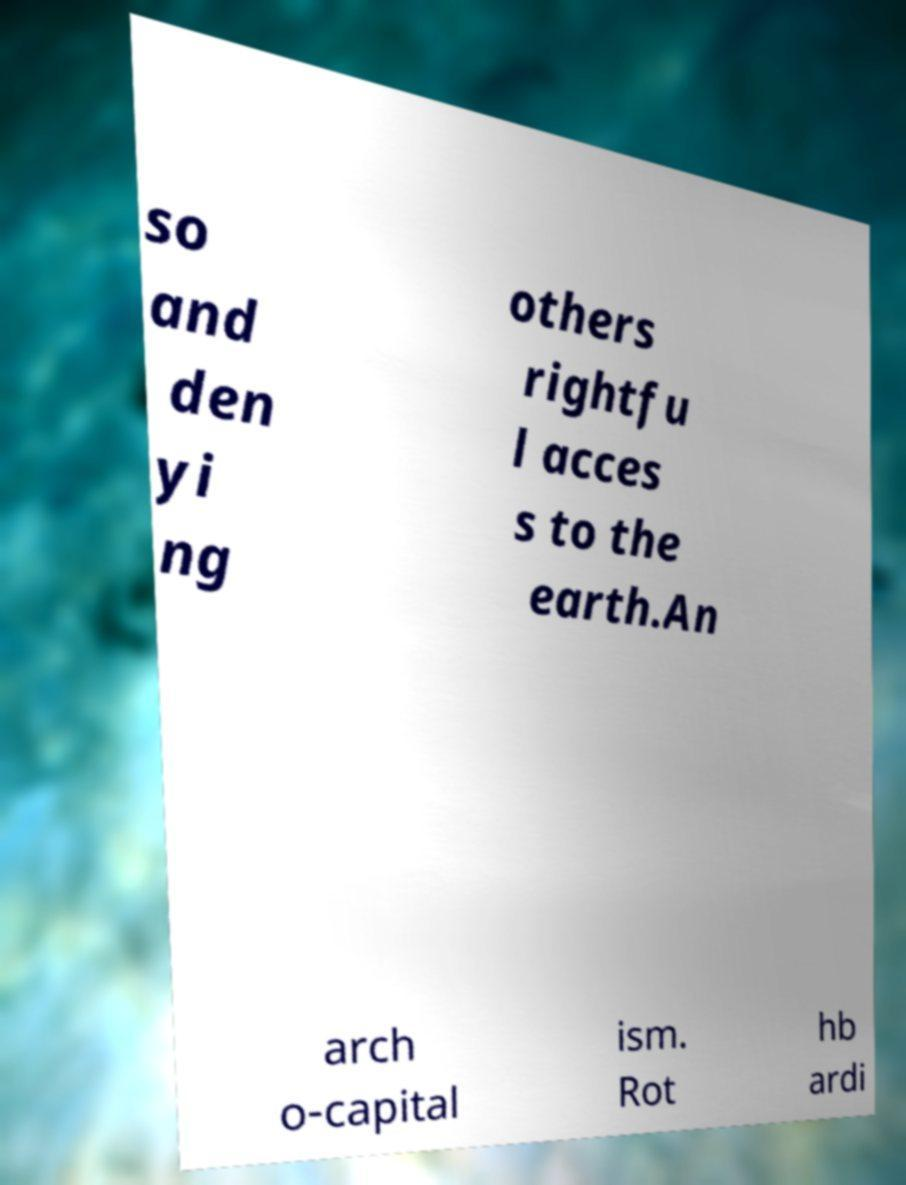I need the written content from this picture converted into text. Can you do that? so and den yi ng others rightfu l acces s to the earth.An arch o-capital ism. Rot hb ardi 